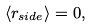Convert formula to latex. <formula><loc_0><loc_0><loc_500><loc_500>\langle r _ { s i d e } \rangle = 0 ,</formula> 